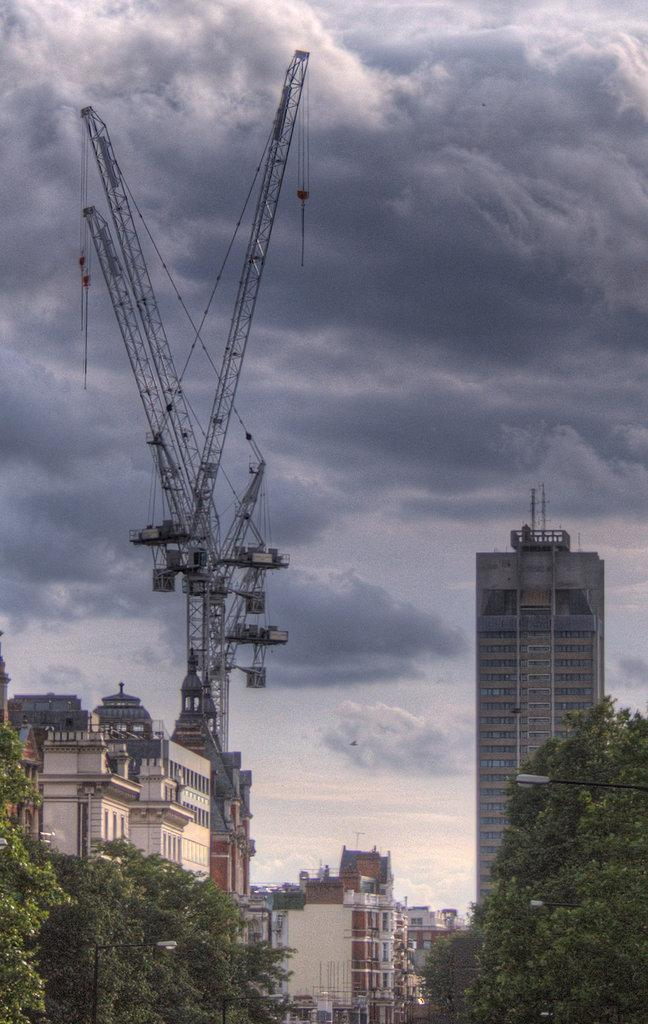What can be seen in the foreground of the picture? There are trees in the foreground of the picture. What is located in the center of the picture? There are buildings and machinery in the center of the picture. What is visible in the background of the picture? The background of the picture is the sky. Can you tell me how many competitors are participating in the sea competition in the image? There is no sea or competition present in the image; it features trees, buildings, machinery, and the sky. What type of air is visible in the image? There is no air visible in the image, as air is not something that can be seen. The image features trees, buildings, machinery, and the sky. 